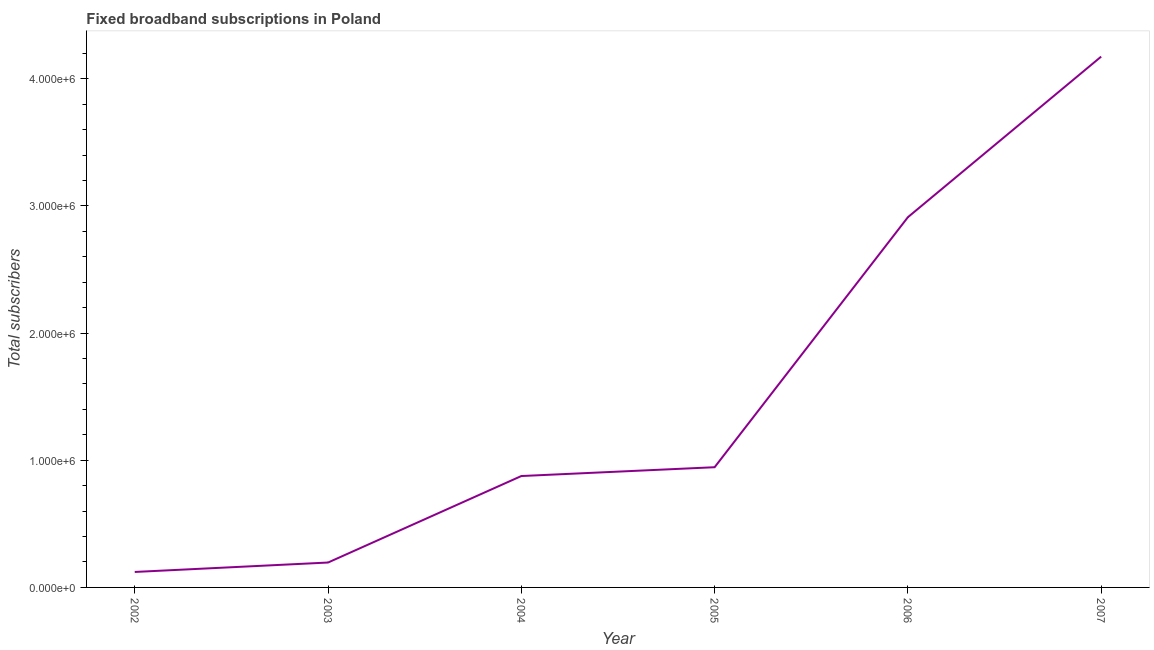What is the total number of fixed broadband subscriptions in 2007?
Your response must be concise. 4.17e+06. Across all years, what is the maximum total number of fixed broadband subscriptions?
Your response must be concise. 4.17e+06. Across all years, what is the minimum total number of fixed broadband subscriptions?
Offer a terse response. 1.22e+05. What is the sum of the total number of fixed broadband subscriptions?
Ensure brevity in your answer.  9.22e+06. What is the difference between the total number of fixed broadband subscriptions in 2005 and 2006?
Provide a short and direct response. -1.97e+06. What is the average total number of fixed broadband subscriptions per year?
Your answer should be compact. 1.54e+06. What is the median total number of fixed broadband subscriptions?
Provide a short and direct response. 9.11e+05. In how many years, is the total number of fixed broadband subscriptions greater than 4000000 ?
Offer a very short reply. 1. What is the ratio of the total number of fixed broadband subscriptions in 2002 to that in 2005?
Provide a short and direct response. 0.13. Is the total number of fixed broadband subscriptions in 2005 less than that in 2006?
Make the answer very short. Yes. Is the difference between the total number of fixed broadband subscriptions in 2002 and 2004 greater than the difference between any two years?
Make the answer very short. No. What is the difference between the highest and the second highest total number of fixed broadband subscriptions?
Your answer should be compact. 1.26e+06. Is the sum of the total number of fixed broadband subscriptions in 2003 and 2004 greater than the maximum total number of fixed broadband subscriptions across all years?
Provide a short and direct response. No. What is the difference between the highest and the lowest total number of fixed broadband subscriptions?
Your answer should be very brief. 4.05e+06. Does the total number of fixed broadband subscriptions monotonically increase over the years?
Offer a very short reply. Yes. How many lines are there?
Your response must be concise. 1. How many years are there in the graph?
Make the answer very short. 6. What is the difference between two consecutive major ticks on the Y-axis?
Keep it short and to the point. 1.00e+06. Does the graph contain any zero values?
Offer a terse response. No. What is the title of the graph?
Make the answer very short. Fixed broadband subscriptions in Poland. What is the label or title of the Y-axis?
Provide a short and direct response. Total subscribers. What is the Total subscribers in 2002?
Your answer should be very brief. 1.22e+05. What is the Total subscribers of 2003?
Offer a very short reply. 1.96e+05. What is the Total subscribers of 2004?
Your answer should be compact. 8.76e+05. What is the Total subscribers in 2005?
Make the answer very short. 9.45e+05. What is the Total subscribers of 2006?
Offer a terse response. 2.91e+06. What is the Total subscribers of 2007?
Offer a terse response. 4.17e+06. What is the difference between the Total subscribers in 2002 and 2003?
Ensure brevity in your answer.  -7.41e+04. What is the difference between the Total subscribers in 2002 and 2004?
Provide a short and direct response. -7.54e+05. What is the difference between the Total subscribers in 2002 and 2005?
Make the answer very short. -8.23e+05. What is the difference between the Total subscribers in 2002 and 2006?
Your answer should be compact. -2.79e+06. What is the difference between the Total subscribers in 2002 and 2007?
Give a very brief answer. -4.05e+06. What is the difference between the Total subscribers in 2003 and 2004?
Your answer should be compact. -6.80e+05. What is the difference between the Total subscribers in 2003 and 2005?
Your answer should be very brief. -7.49e+05. What is the difference between the Total subscribers in 2003 and 2006?
Keep it short and to the point. -2.72e+06. What is the difference between the Total subscribers in 2003 and 2007?
Offer a very short reply. -3.98e+06. What is the difference between the Total subscribers in 2004 and 2005?
Make the answer very short. -6.93e+04. What is the difference between the Total subscribers in 2004 and 2006?
Make the answer very short. -2.04e+06. What is the difference between the Total subscribers in 2004 and 2007?
Your answer should be very brief. -3.30e+06. What is the difference between the Total subscribers in 2005 and 2006?
Make the answer very short. -1.97e+06. What is the difference between the Total subscribers in 2005 and 2007?
Make the answer very short. -3.23e+06. What is the difference between the Total subscribers in 2006 and 2007?
Keep it short and to the point. -1.26e+06. What is the ratio of the Total subscribers in 2002 to that in 2003?
Offer a very short reply. 0.62. What is the ratio of the Total subscribers in 2002 to that in 2004?
Give a very brief answer. 0.14. What is the ratio of the Total subscribers in 2002 to that in 2005?
Give a very brief answer. 0.13. What is the ratio of the Total subscribers in 2002 to that in 2006?
Provide a short and direct response. 0.04. What is the ratio of the Total subscribers in 2002 to that in 2007?
Offer a terse response. 0.03. What is the ratio of the Total subscribers in 2003 to that in 2004?
Your answer should be compact. 0.22. What is the ratio of the Total subscribers in 2003 to that in 2005?
Make the answer very short. 0.21. What is the ratio of the Total subscribers in 2003 to that in 2006?
Give a very brief answer. 0.07. What is the ratio of the Total subscribers in 2003 to that in 2007?
Your answer should be compact. 0.05. What is the ratio of the Total subscribers in 2004 to that in 2005?
Make the answer very short. 0.93. What is the ratio of the Total subscribers in 2004 to that in 2006?
Offer a terse response. 0.3. What is the ratio of the Total subscribers in 2004 to that in 2007?
Your answer should be very brief. 0.21. What is the ratio of the Total subscribers in 2005 to that in 2006?
Provide a succinct answer. 0.33. What is the ratio of the Total subscribers in 2005 to that in 2007?
Ensure brevity in your answer.  0.23. What is the ratio of the Total subscribers in 2006 to that in 2007?
Make the answer very short. 0.7. 